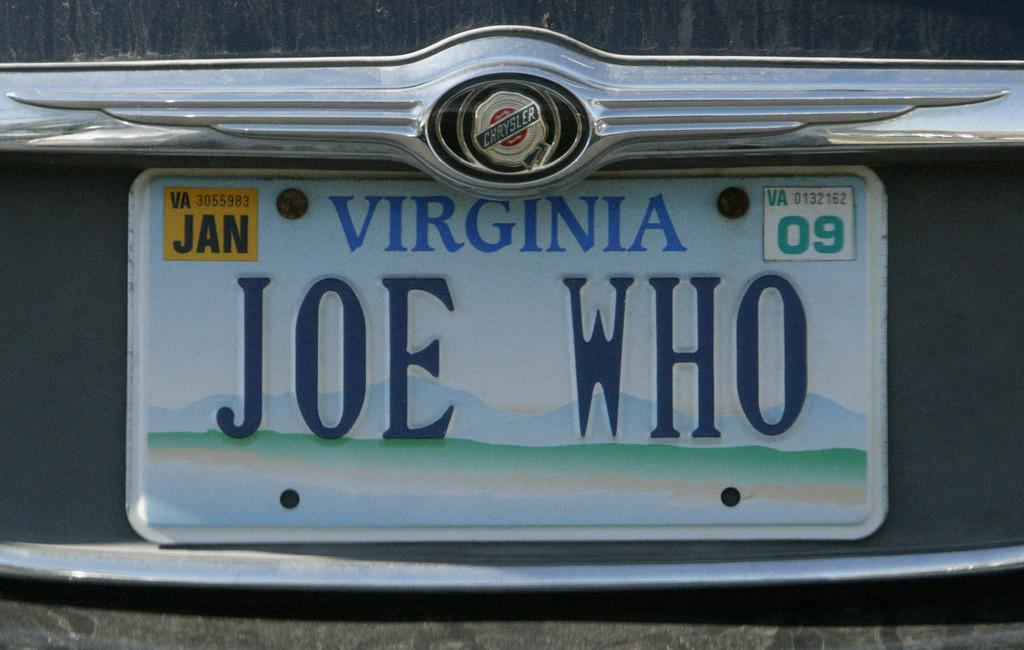<image>
Present a compact description of the photo's key features. a license plate that is from the state of Virginia 